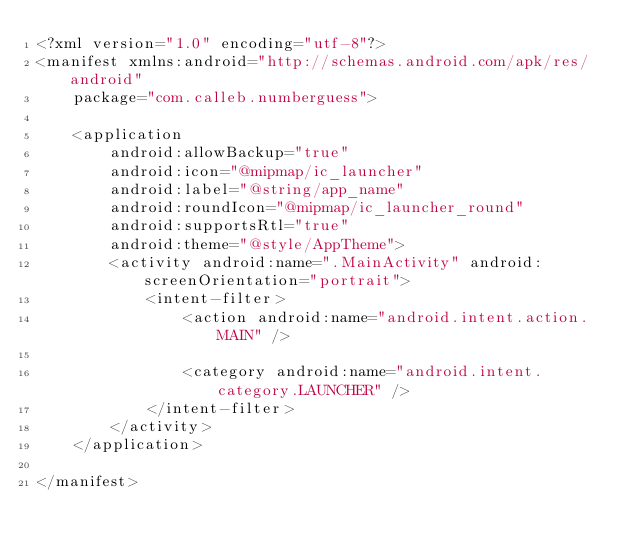Convert code to text. <code><loc_0><loc_0><loc_500><loc_500><_XML_><?xml version="1.0" encoding="utf-8"?>
<manifest xmlns:android="http://schemas.android.com/apk/res/android"
    package="com.calleb.numberguess">

    <application
        android:allowBackup="true"
        android:icon="@mipmap/ic_launcher"
        android:label="@string/app_name"
        android:roundIcon="@mipmap/ic_launcher_round"
        android:supportsRtl="true"
        android:theme="@style/AppTheme">
        <activity android:name=".MainActivity" android:screenOrientation="portrait">
            <intent-filter>
                <action android:name="android.intent.action.MAIN" />

                <category android:name="android.intent.category.LAUNCHER" />
            </intent-filter>
        </activity>
    </application>

</manifest></code> 